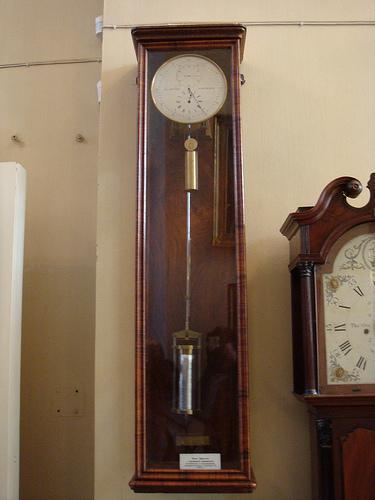How many clocks are in the photo?
Give a very brief answer. 2. 